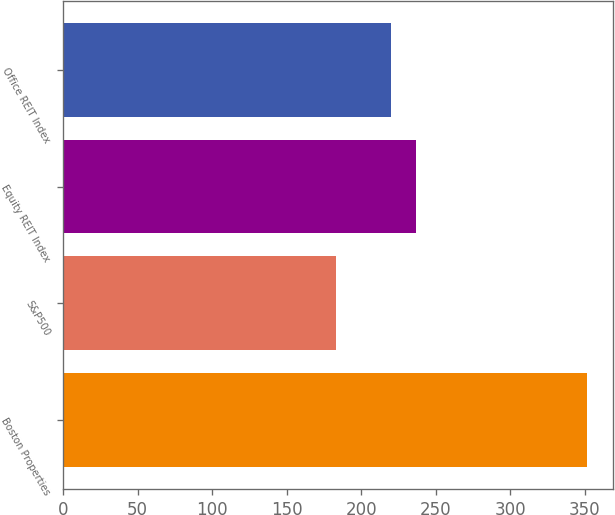Convert chart to OTSL. <chart><loc_0><loc_0><loc_500><loc_500><bar_chart><fcel>Boston Properties<fcel>S&P500<fcel>Equity REIT Index<fcel>Office REIT Index<nl><fcel>351.15<fcel>182.86<fcel>236.75<fcel>219.92<nl></chart> 